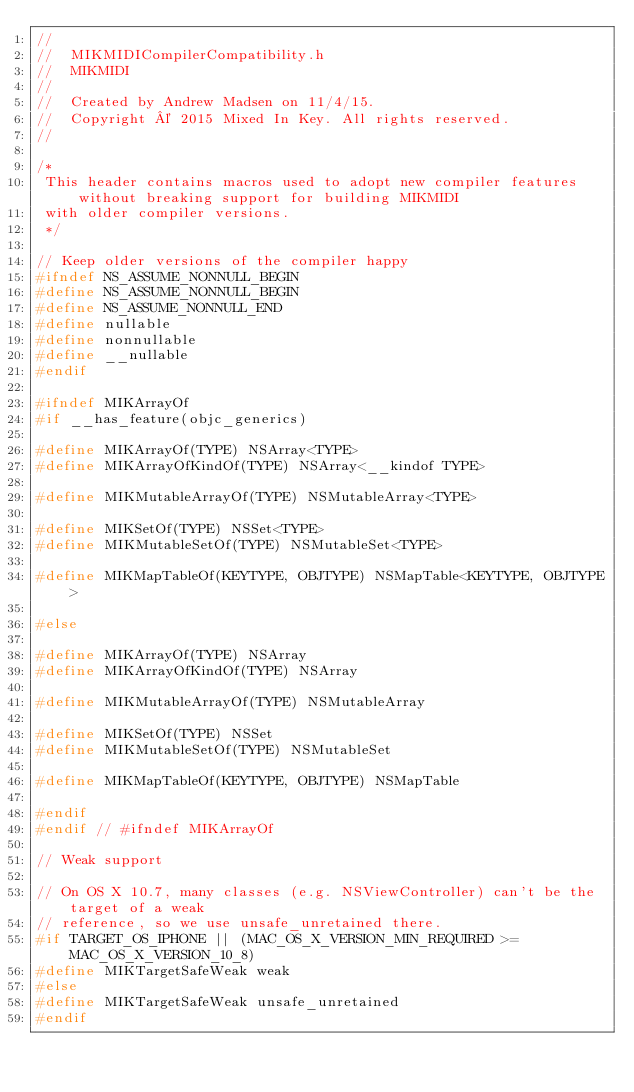Convert code to text. <code><loc_0><loc_0><loc_500><loc_500><_C_>//
//  MIKMIDICompilerCompatibility.h
//  MIKMIDI
//
//  Created by Andrew Madsen on 11/4/15.
//  Copyright © 2015 Mixed In Key. All rights reserved.
//

/*
 This header contains macros used to adopt new compiler features without breaking support for building MIKMIDI
 with older compiler versions.
 */

// Keep older versions of the compiler happy
#ifndef NS_ASSUME_NONNULL_BEGIN
#define NS_ASSUME_NONNULL_BEGIN
#define NS_ASSUME_NONNULL_END
#define nullable
#define nonnullable
#define __nullable
#endif

#ifndef MIKArrayOf
#if __has_feature(objc_generics)

#define MIKArrayOf(TYPE) NSArray<TYPE>
#define MIKArrayOfKindOf(TYPE) NSArray<__kindof TYPE>

#define MIKMutableArrayOf(TYPE) NSMutableArray<TYPE>

#define MIKSetOf(TYPE) NSSet<TYPE>
#define MIKMutableSetOf(TYPE) NSMutableSet<TYPE>

#define MIKMapTableOf(KEYTYPE, OBJTYPE) NSMapTable<KEYTYPE, OBJTYPE>

#else

#define MIKArrayOf(TYPE) NSArray
#define MIKArrayOfKindOf(TYPE) NSArray

#define MIKMutableArrayOf(TYPE) NSMutableArray

#define MIKSetOf(TYPE) NSSet
#define MIKMutableSetOf(TYPE) NSMutableSet

#define MIKMapTableOf(KEYTYPE, OBJTYPE) NSMapTable

#endif
#endif // #ifndef MIKArrayOf

// Weak support

// On OS X 10.7, many classes (e.g. NSViewController) can't be the target of a weak
// reference, so we use unsafe_unretained there.
#if TARGET_OS_IPHONE || (MAC_OS_X_VERSION_MIN_REQUIRED >= MAC_OS_X_VERSION_10_8)
#define MIKTargetSafeWeak weak
#else
#define MIKTargetSafeWeak unsafe_unretained
#endif</code> 